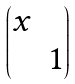Convert formula to latex. <formula><loc_0><loc_0><loc_500><loc_500>\begin{pmatrix} x & \\ & 1 \end{pmatrix}</formula> 